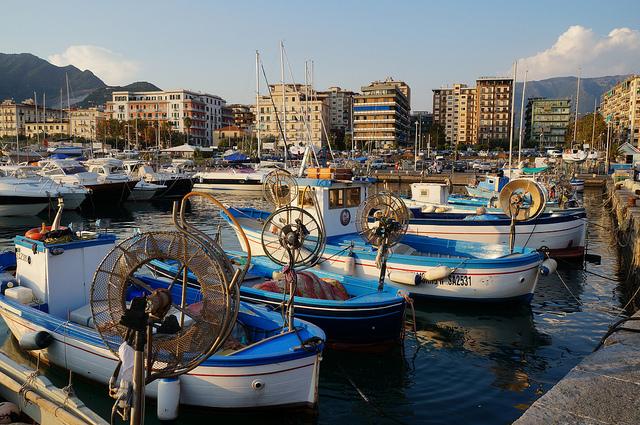How many boats re blue?
Keep it brief. 5. Where was this picture taken?
Keep it brief. Marina. Is it daytime?
Short answer required. Yes. 